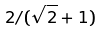Convert formula to latex. <formula><loc_0><loc_0><loc_500><loc_500>2 / ( \sqrt { 2 } + 1 )</formula> 